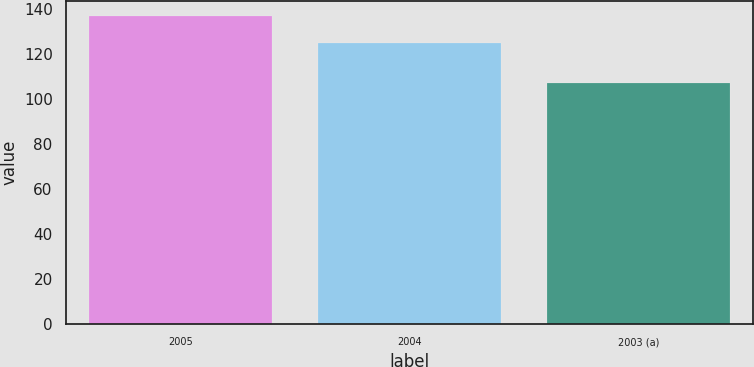Convert chart. <chart><loc_0><loc_0><loc_500><loc_500><bar_chart><fcel>2005<fcel>2004<fcel>2003 (a)<nl><fcel>136.6<fcel>124.8<fcel>107<nl></chart> 